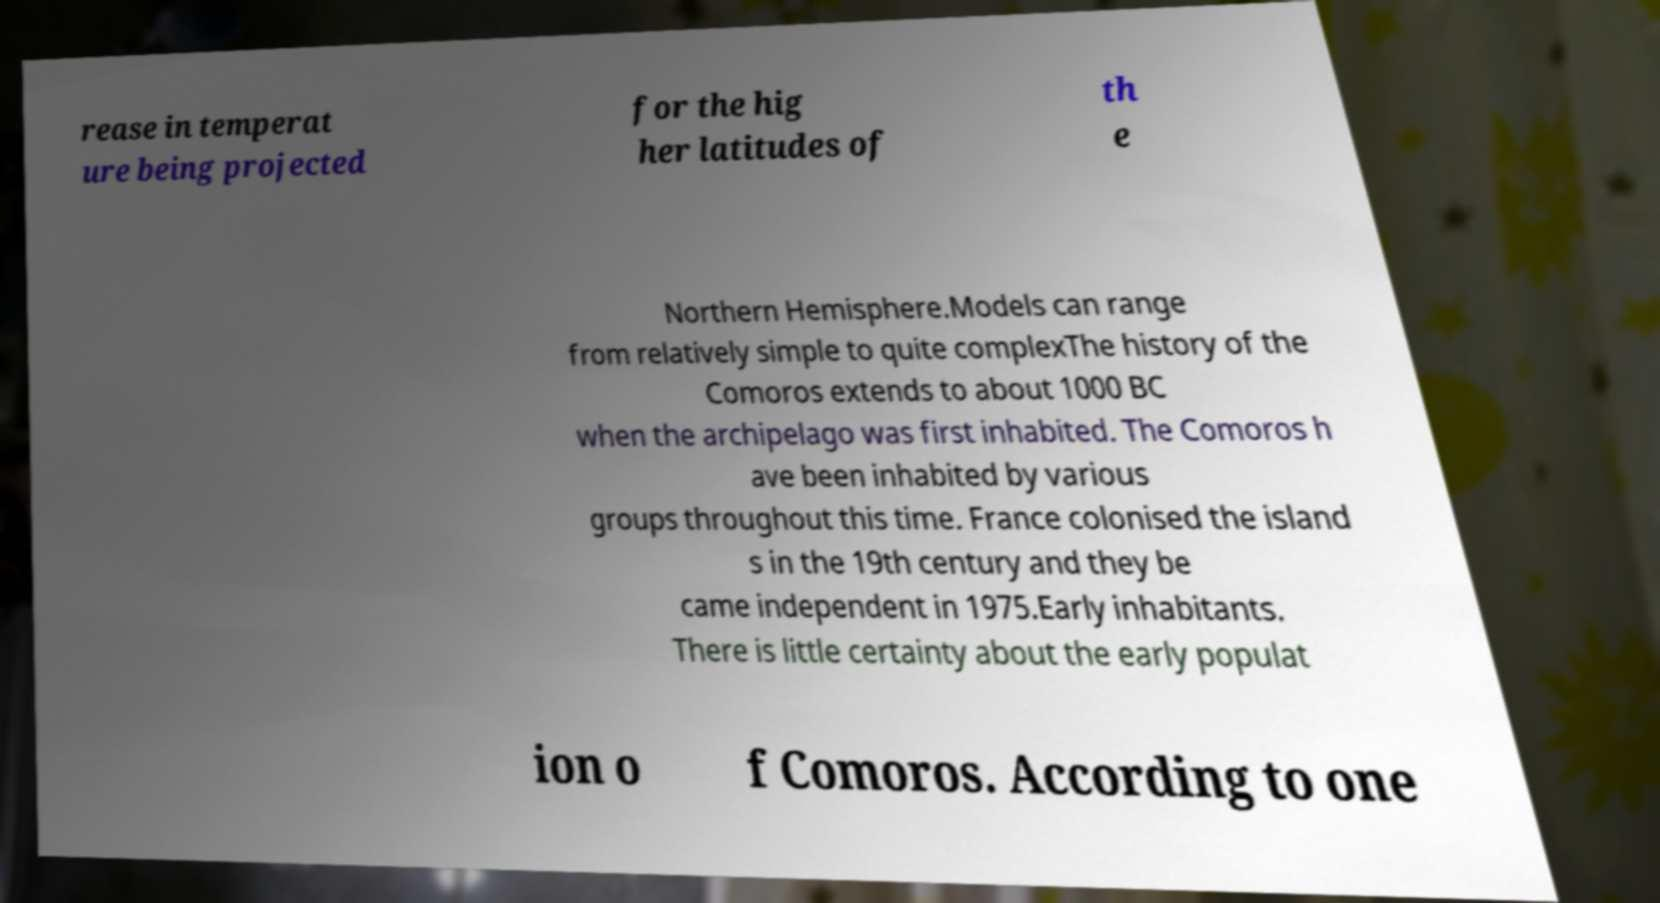What messages or text are displayed in this image? I need them in a readable, typed format. rease in temperat ure being projected for the hig her latitudes of th e Northern Hemisphere.Models can range from relatively simple to quite complexThe history of the Comoros extends to about 1000 BC when the archipelago was first inhabited. The Comoros h ave been inhabited by various groups throughout this time. France colonised the island s in the 19th century and they be came independent in 1975.Early inhabitants. There is little certainty about the early populat ion o f Comoros. According to one 